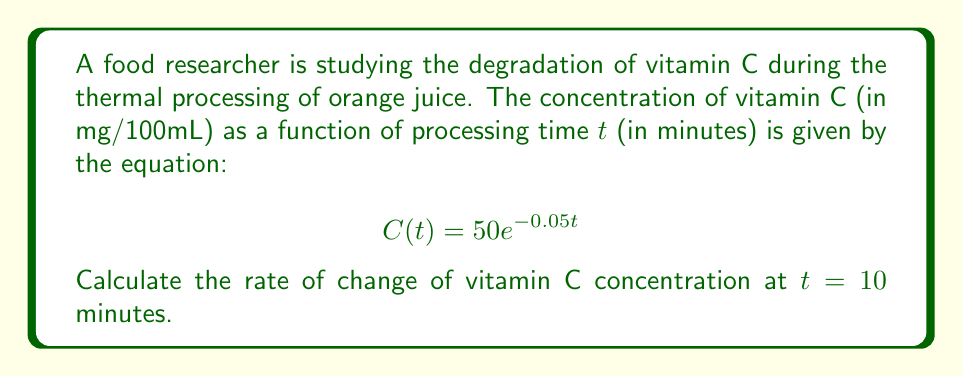What is the answer to this math problem? To find the rate of change of vitamin C concentration at t = 10 minutes, we need to calculate the derivative of the given function C(t) and evaluate it at t = 10.

Step 1: Find the derivative of C(t)
$$\frac{d}{dt}C(t) = \frac{d}{dt}(50e^{-0.05t})$$
Using the chain rule, we get:
$$\frac{d}{dt}C(t) = 50 \cdot (-0.05) \cdot e^{-0.05t}$$
$$\frac{d}{dt}C(t) = -2.5e^{-0.05t}$$

Step 2: Evaluate the derivative at t = 10
$$\frac{d}{dt}C(10) = -2.5e^{-0.05(10)}$$
$$\frac{d}{dt}C(10) = -2.5e^{-0.5}$$
$$\frac{d}{dt}C(10) = -2.5 \cdot 0.6065$$
$$\frac{d}{dt}C(10) = -1.51625$$

Step 3: Interpret the result
The rate of change of vitamin C concentration at t = 10 minutes is approximately -1.52 mg/100mL per minute. The negative value indicates that the concentration is decreasing.
Answer: $-1.52$ mg/100mL per minute 